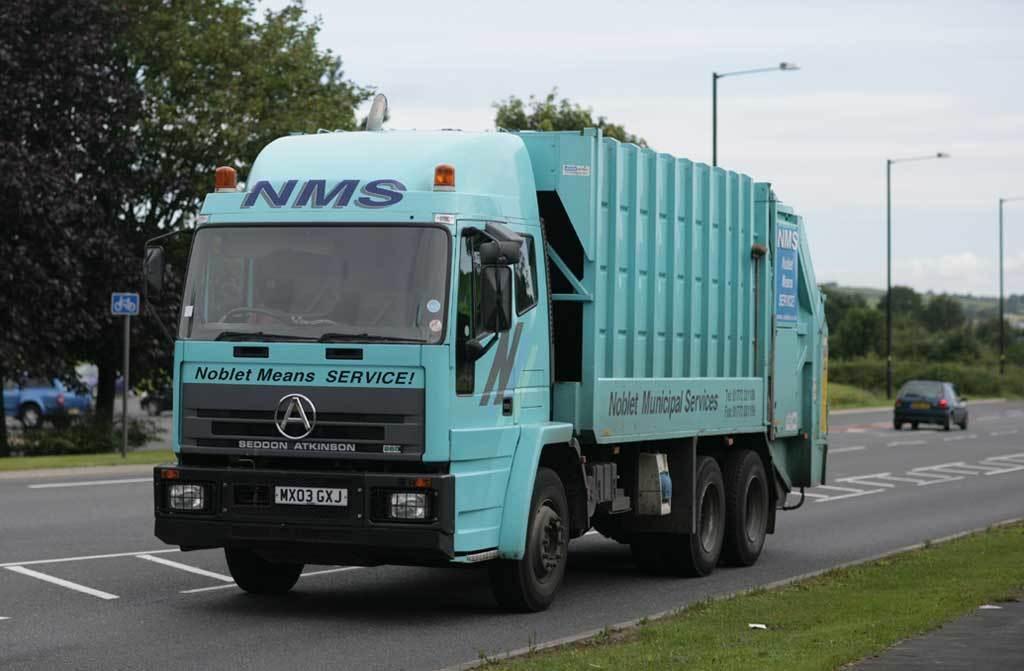Please provide a concise description of this image. In this image in the center there are vehicles moving on the road. In the front there's grass on the ground. In the background there are trees, there are light poles and there is a car which is blue in colour moving on the road and there is grass on the ground and the sky is cloudy. 